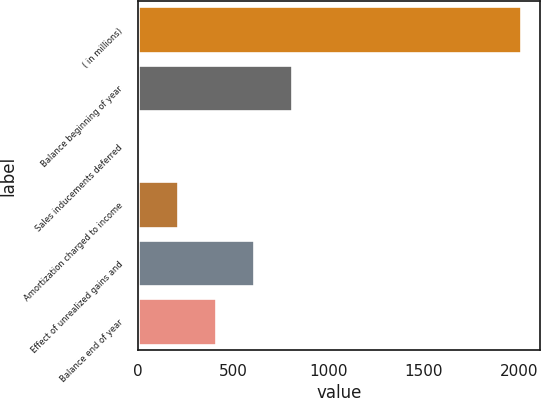Convert chart. <chart><loc_0><loc_0><loc_500><loc_500><bar_chart><fcel>( in millions)<fcel>Balance beginning of year<fcel>Sales inducements deferred<fcel>Amortization charged to income<fcel>Effect of unrealized gains and<fcel>Balance end of year<nl><fcel>2010<fcel>812.4<fcel>14<fcel>213.6<fcel>612.8<fcel>413.2<nl></chart> 